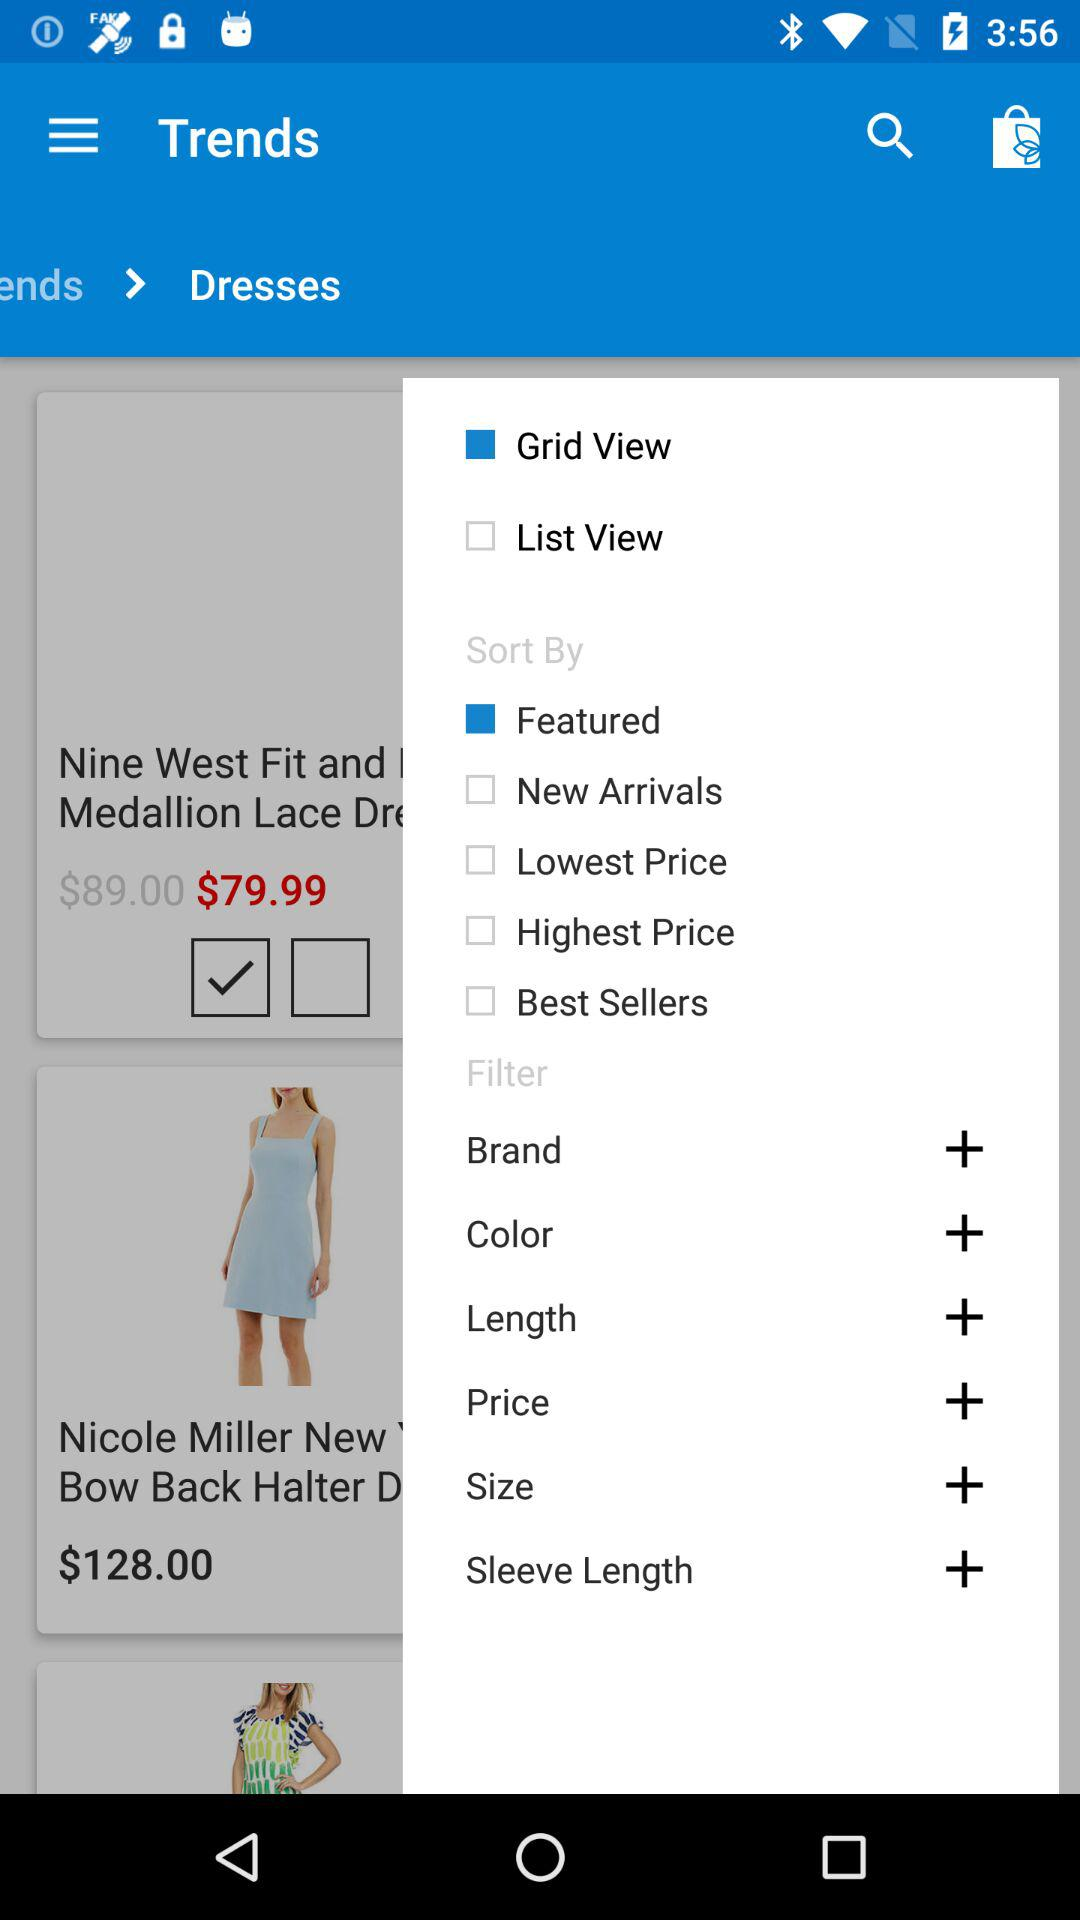What is the cost of the Nine West dress? The cost is $79.99. 